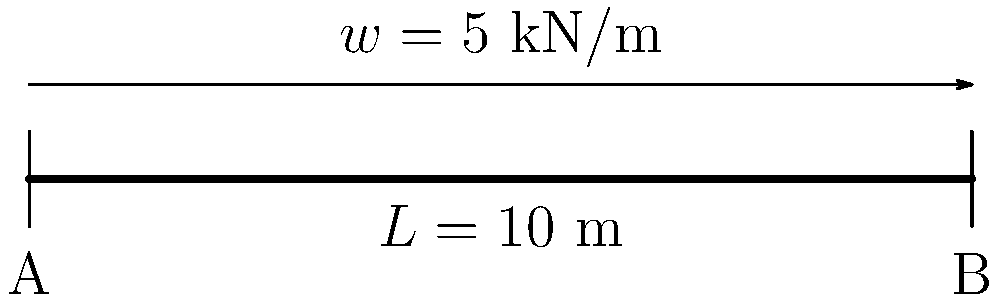A simply supported beam of length $L = 10$ m is subjected to a uniformly distributed load of $w = 5$ kN/m along its entire length, as shown in the figure. Calculate the maximum bending stress $\sigma_{max}$ in the beam if it has a rectangular cross-section with width $b = 0.15$ m and height $h = 0.3$ m. To find the maximum bending stress, we'll follow these steps:

1) Calculate the maximum bending moment:
   For a simply supported beam with uniform load, the maximum bending moment occurs at the center:
   $$M_{max} = \frac{wL^2}{8} = \frac{5 \times 10^2}{8} = 62.5 \text{ kN⋅m}$$

2) Calculate the moment of inertia for the rectangular cross-section:
   $$I = \frac{bh^3}{12} = \frac{0.15 \times 0.3^3}{12} = 3.375 \times 10^{-4} \text{ m}^4$$

3) Calculate the distance from the neutral axis to the extreme fiber:
   $$y = \frac{h}{2} = \frac{0.3}{2} = 0.15 \text{ m}$$

4) Use the flexure formula to calculate the maximum bending stress:
   $$\sigma_{max} = \frac{M_{max}y}{I} = \frac{62.5 \times 0.15}{3.375 \times 10^{-4}} = 27.78 \text{ MPa}$$
Answer: 27.78 MPa 